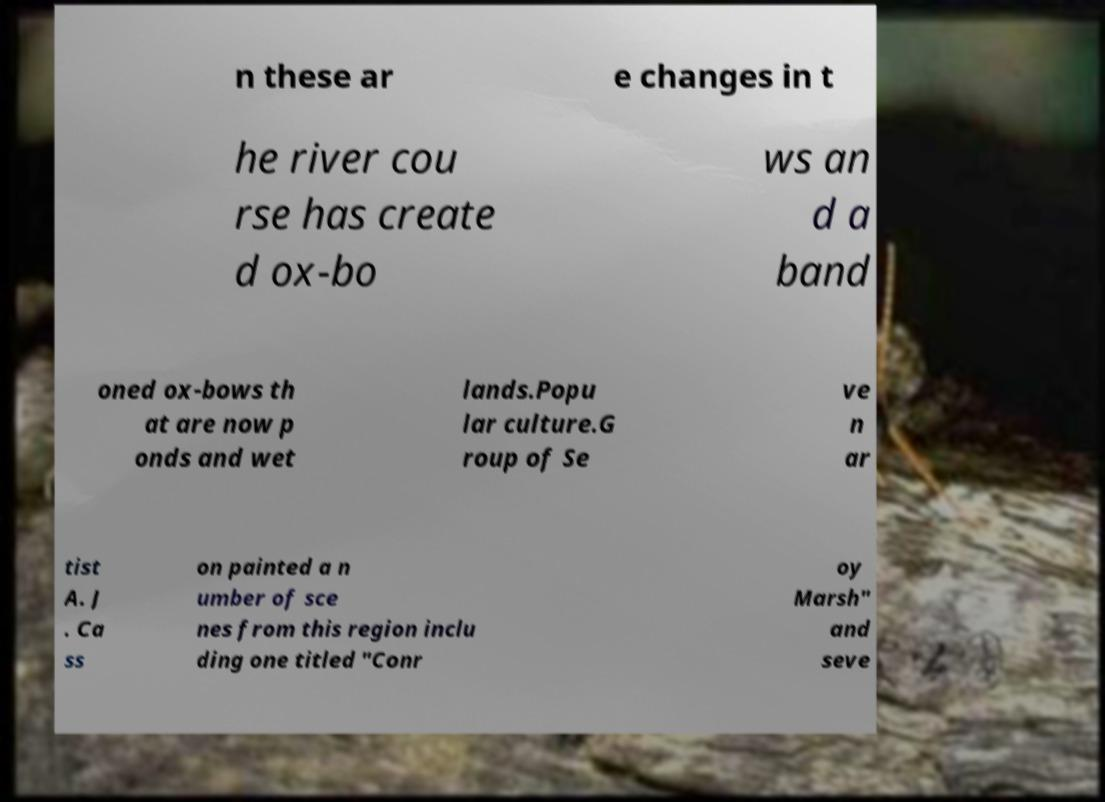Can you accurately transcribe the text from the provided image for me? n these ar e changes in t he river cou rse has create d ox-bo ws an d a band oned ox-bows th at are now p onds and wet lands.Popu lar culture.G roup of Se ve n ar tist A. J . Ca ss on painted a n umber of sce nes from this region inclu ding one titled "Conr oy Marsh" and seve 